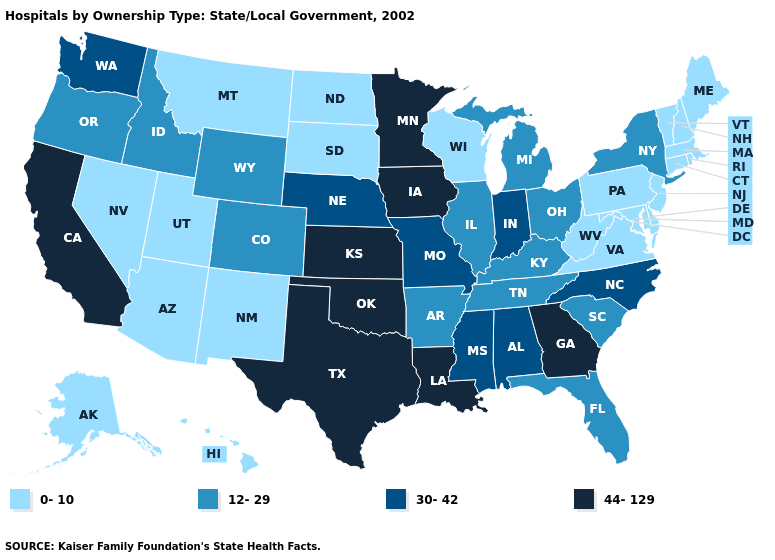What is the value of Wisconsin?
Answer briefly. 0-10. Name the states that have a value in the range 0-10?
Be succinct. Alaska, Arizona, Connecticut, Delaware, Hawaii, Maine, Maryland, Massachusetts, Montana, Nevada, New Hampshire, New Jersey, New Mexico, North Dakota, Pennsylvania, Rhode Island, South Dakota, Utah, Vermont, Virginia, West Virginia, Wisconsin. Name the states that have a value in the range 44-129?
Write a very short answer. California, Georgia, Iowa, Kansas, Louisiana, Minnesota, Oklahoma, Texas. Is the legend a continuous bar?
Keep it brief. No. What is the value of Tennessee?
Answer briefly. 12-29. Name the states that have a value in the range 12-29?
Give a very brief answer. Arkansas, Colorado, Florida, Idaho, Illinois, Kentucky, Michigan, New York, Ohio, Oregon, South Carolina, Tennessee, Wyoming. Name the states that have a value in the range 12-29?
Quick response, please. Arkansas, Colorado, Florida, Idaho, Illinois, Kentucky, Michigan, New York, Ohio, Oregon, South Carolina, Tennessee, Wyoming. Does Arkansas have the highest value in the South?
Short answer required. No. What is the value of Rhode Island?
Keep it brief. 0-10. What is the highest value in the USA?
Be succinct. 44-129. Name the states that have a value in the range 30-42?
Keep it brief. Alabama, Indiana, Mississippi, Missouri, Nebraska, North Carolina, Washington. What is the value of New Mexico?
Short answer required. 0-10. Among the states that border Georgia , which have the highest value?
Short answer required. Alabama, North Carolina. Does Maine have the same value as Alaska?
Give a very brief answer. Yes. Name the states that have a value in the range 44-129?
Write a very short answer. California, Georgia, Iowa, Kansas, Louisiana, Minnesota, Oklahoma, Texas. 